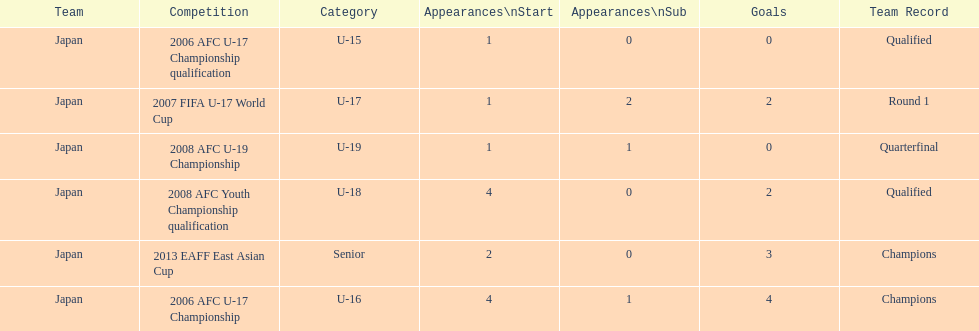Yoichiro kakitani scored above 2 goals in how many major competitions? 2. 